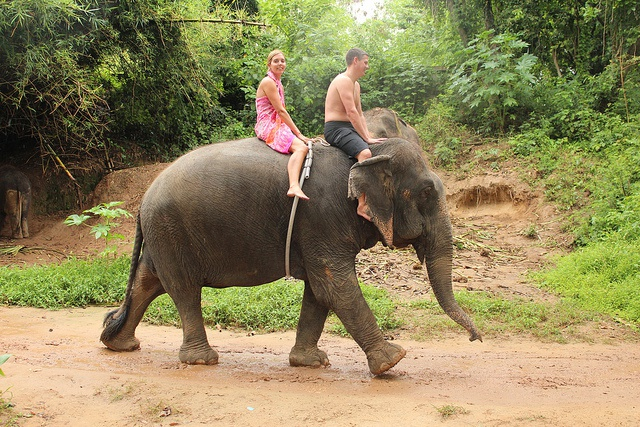Describe the objects in this image and their specific colors. I can see elephant in darkgreen, black, maroon, and gray tones, people in darkgreen, tan, gray, and salmon tones, people in darkgreen, lightgray, lightpink, tan, and salmon tones, elephant in darkgreen, black, maroon, and gray tones, and elephant in darkgreen, tan, and gray tones in this image. 